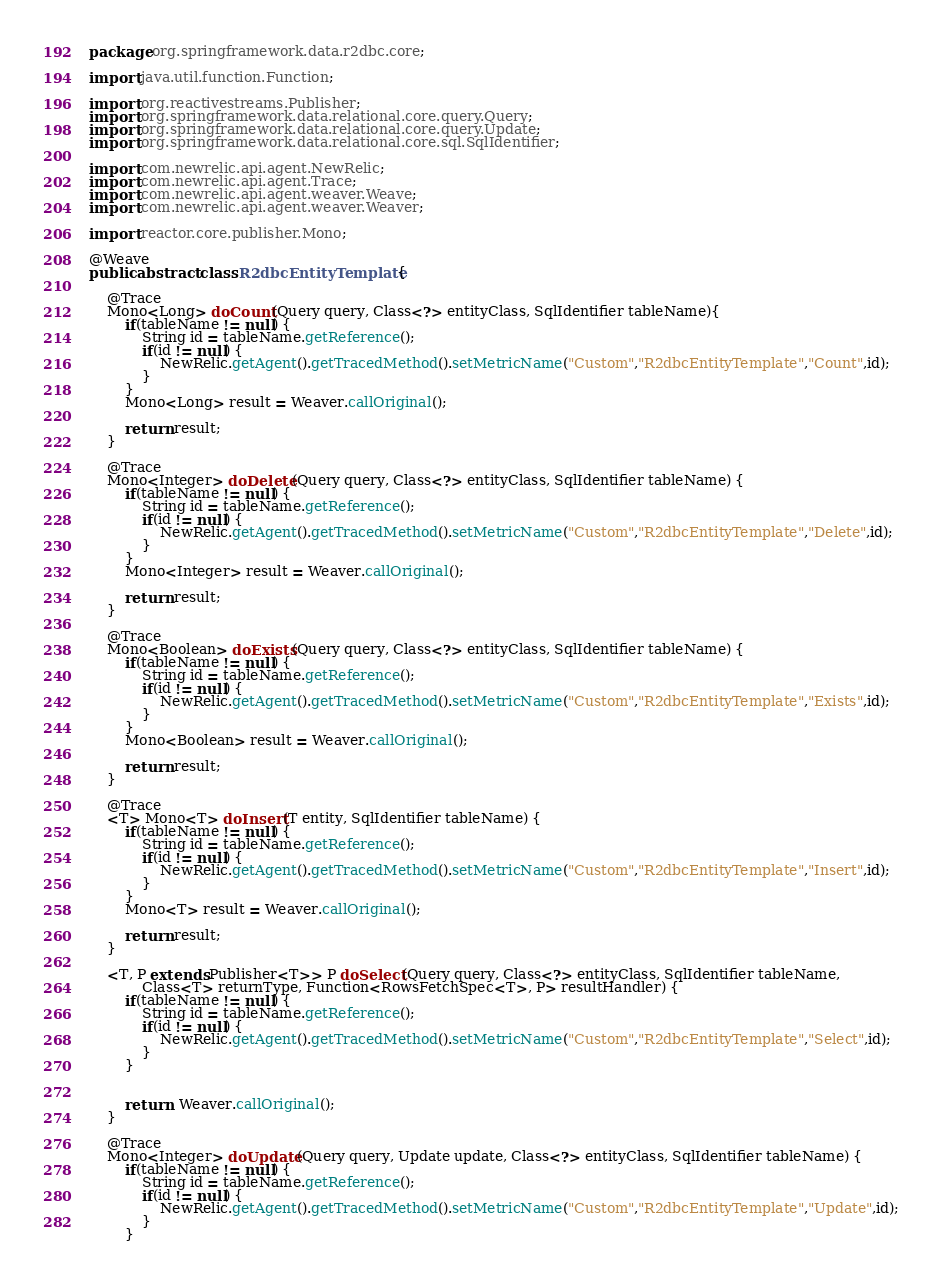Convert code to text. <code><loc_0><loc_0><loc_500><loc_500><_Java_>package org.springframework.data.r2dbc.core;

import java.util.function.Function;

import org.reactivestreams.Publisher;
import org.springframework.data.relational.core.query.Query;
import org.springframework.data.relational.core.query.Update;
import org.springframework.data.relational.core.sql.SqlIdentifier;

import com.newrelic.api.agent.NewRelic;
import com.newrelic.api.agent.Trace;
import com.newrelic.api.agent.weaver.Weave;
import com.newrelic.api.agent.weaver.Weaver;

import reactor.core.publisher.Mono;

@Weave
public abstract class R2dbcEntityTemplate {

	@Trace
	Mono<Long> doCount(Query query, Class<?> entityClass, SqlIdentifier tableName){
		if(tableName != null) {
			String id = tableName.getReference();
			if(id != null) {
				NewRelic.getAgent().getTracedMethod().setMetricName("Custom","R2dbcEntityTemplate","Count",id);
			}
		}
		Mono<Long> result = Weaver.callOriginal();
		
		return result;
	}
	
	@Trace
	Mono<Integer> doDelete(Query query, Class<?> entityClass, SqlIdentifier tableName) {
		if(tableName != null) {
			String id = tableName.getReference();
			if(id != null) {
				NewRelic.getAgent().getTracedMethod().setMetricName("Custom","R2dbcEntityTemplate","Delete",id);
			}
		}
		Mono<Integer> result = Weaver.callOriginal();
		
		return result;
	}
	
	@Trace
	Mono<Boolean> doExists(Query query, Class<?> entityClass, SqlIdentifier tableName) {
		if(tableName != null) {
			String id = tableName.getReference();
			if(id != null) {
				NewRelic.getAgent().getTracedMethod().setMetricName("Custom","R2dbcEntityTemplate","Exists",id);
			}
		}
		Mono<Boolean> result = Weaver.callOriginal();
		
		return result;
	}
	
	@Trace
	<T> Mono<T> doInsert(T entity, SqlIdentifier tableName) {
		if(tableName != null) {
			String id = tableName.getReference();
			if(id != null) {
				NewRelic.getAgent().getTracedMethod().setMetricName("Custom","R2dbcEntityTemplate","Insert",id);
			}
		}
		Mono<T> result = Weaver.callOriginal();
		
		return result;
	}
	
	<T, P extends Publisher<T>> P doSelect(Query query, Class<?> entityClass, SqlIdentifier tableName,
			Class<T> returnType, Function<RowsFetchSpec<T>, P> resultHandler) {
		if(tableName != null) {
			String id = tableName.getReference();
			if(id != null) {
				NewRelic.getAgent().getTracedMethod().setMetricName("Custom","R2dbcEntityTemplate","Select",id);
			}
		}
		
		
		return  Weaver.callOriginal();
	}
	
	@Trace
	Mono<Integer> doUpdate(Query query, Update update, Class<?> entityClass, SqlIdentifier tableName) {
		if(tableName != null) {
			String id = tableName.getReference();
			if(id != null) {
				NewRelic.getAgent().getTracedMethod().setMetricName("Custom","R2dbcEntityTemplate","Update",id);
			}
		}</code> 